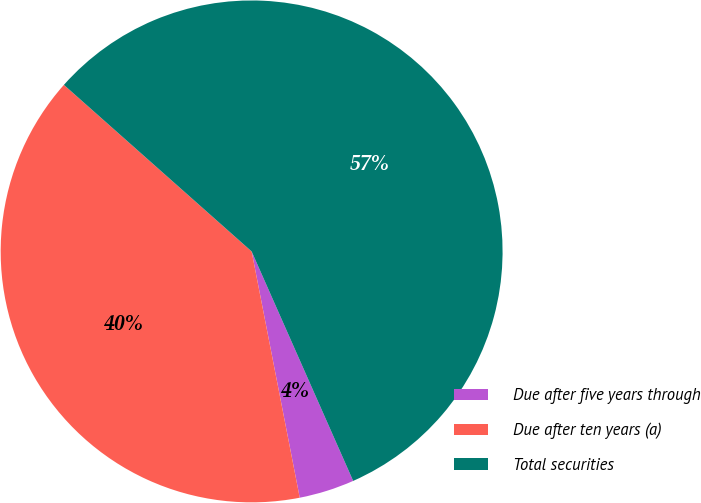Convert chart. <chart><loc_0><loc_0><loc_500><loc_500><pie_chart><fcel>Due after five years through<fcel>Due after ten years (a)<fcel>Total securities<nl><fcel>3.56%<fcel>39.62%<fcel>56.82%<nl></chart> 